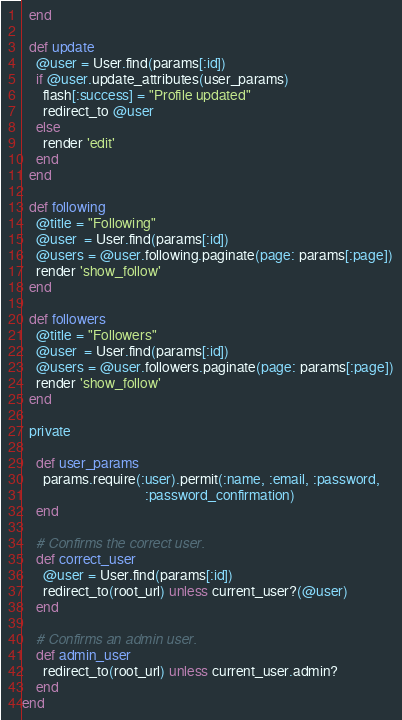Convert code to text. <code><loc_0><loc_0><loc_500><loc_500><_Ruby_>  end

  def update
    @user = User.find(params[:id])
    if @user.update_attributes(user_params)
      flash[:success] = "Profile updated"
      redirect_to @user
    else
      render 'edit'
    end
  end

  def following
    @title = "Following"
    @user  = User.find(params[:id])
    @users = @user.following.paginate(page: params[:page])
    render 'show_follow'
  end

  def followers
    @title = "Followers"
    @user  = User.find(params[:id])
    @users = @user.followers.paginate(page: params[:page])
    render 'show_follow'
  end

  private

    def user_params
      params.require(:user).permit(:name, :email, :password,
                                   :password_confirmation)
    end

    # Confirms the correct user.
    def correct_user
      @user = User.find(params[:id])
      redirect_to(root_url) unless current_user?(@user)
    end

    # Confirms an admin user.
    def admin_user
      redirect_to(root_url) unless current_user.admin?
    end
end
</code> 